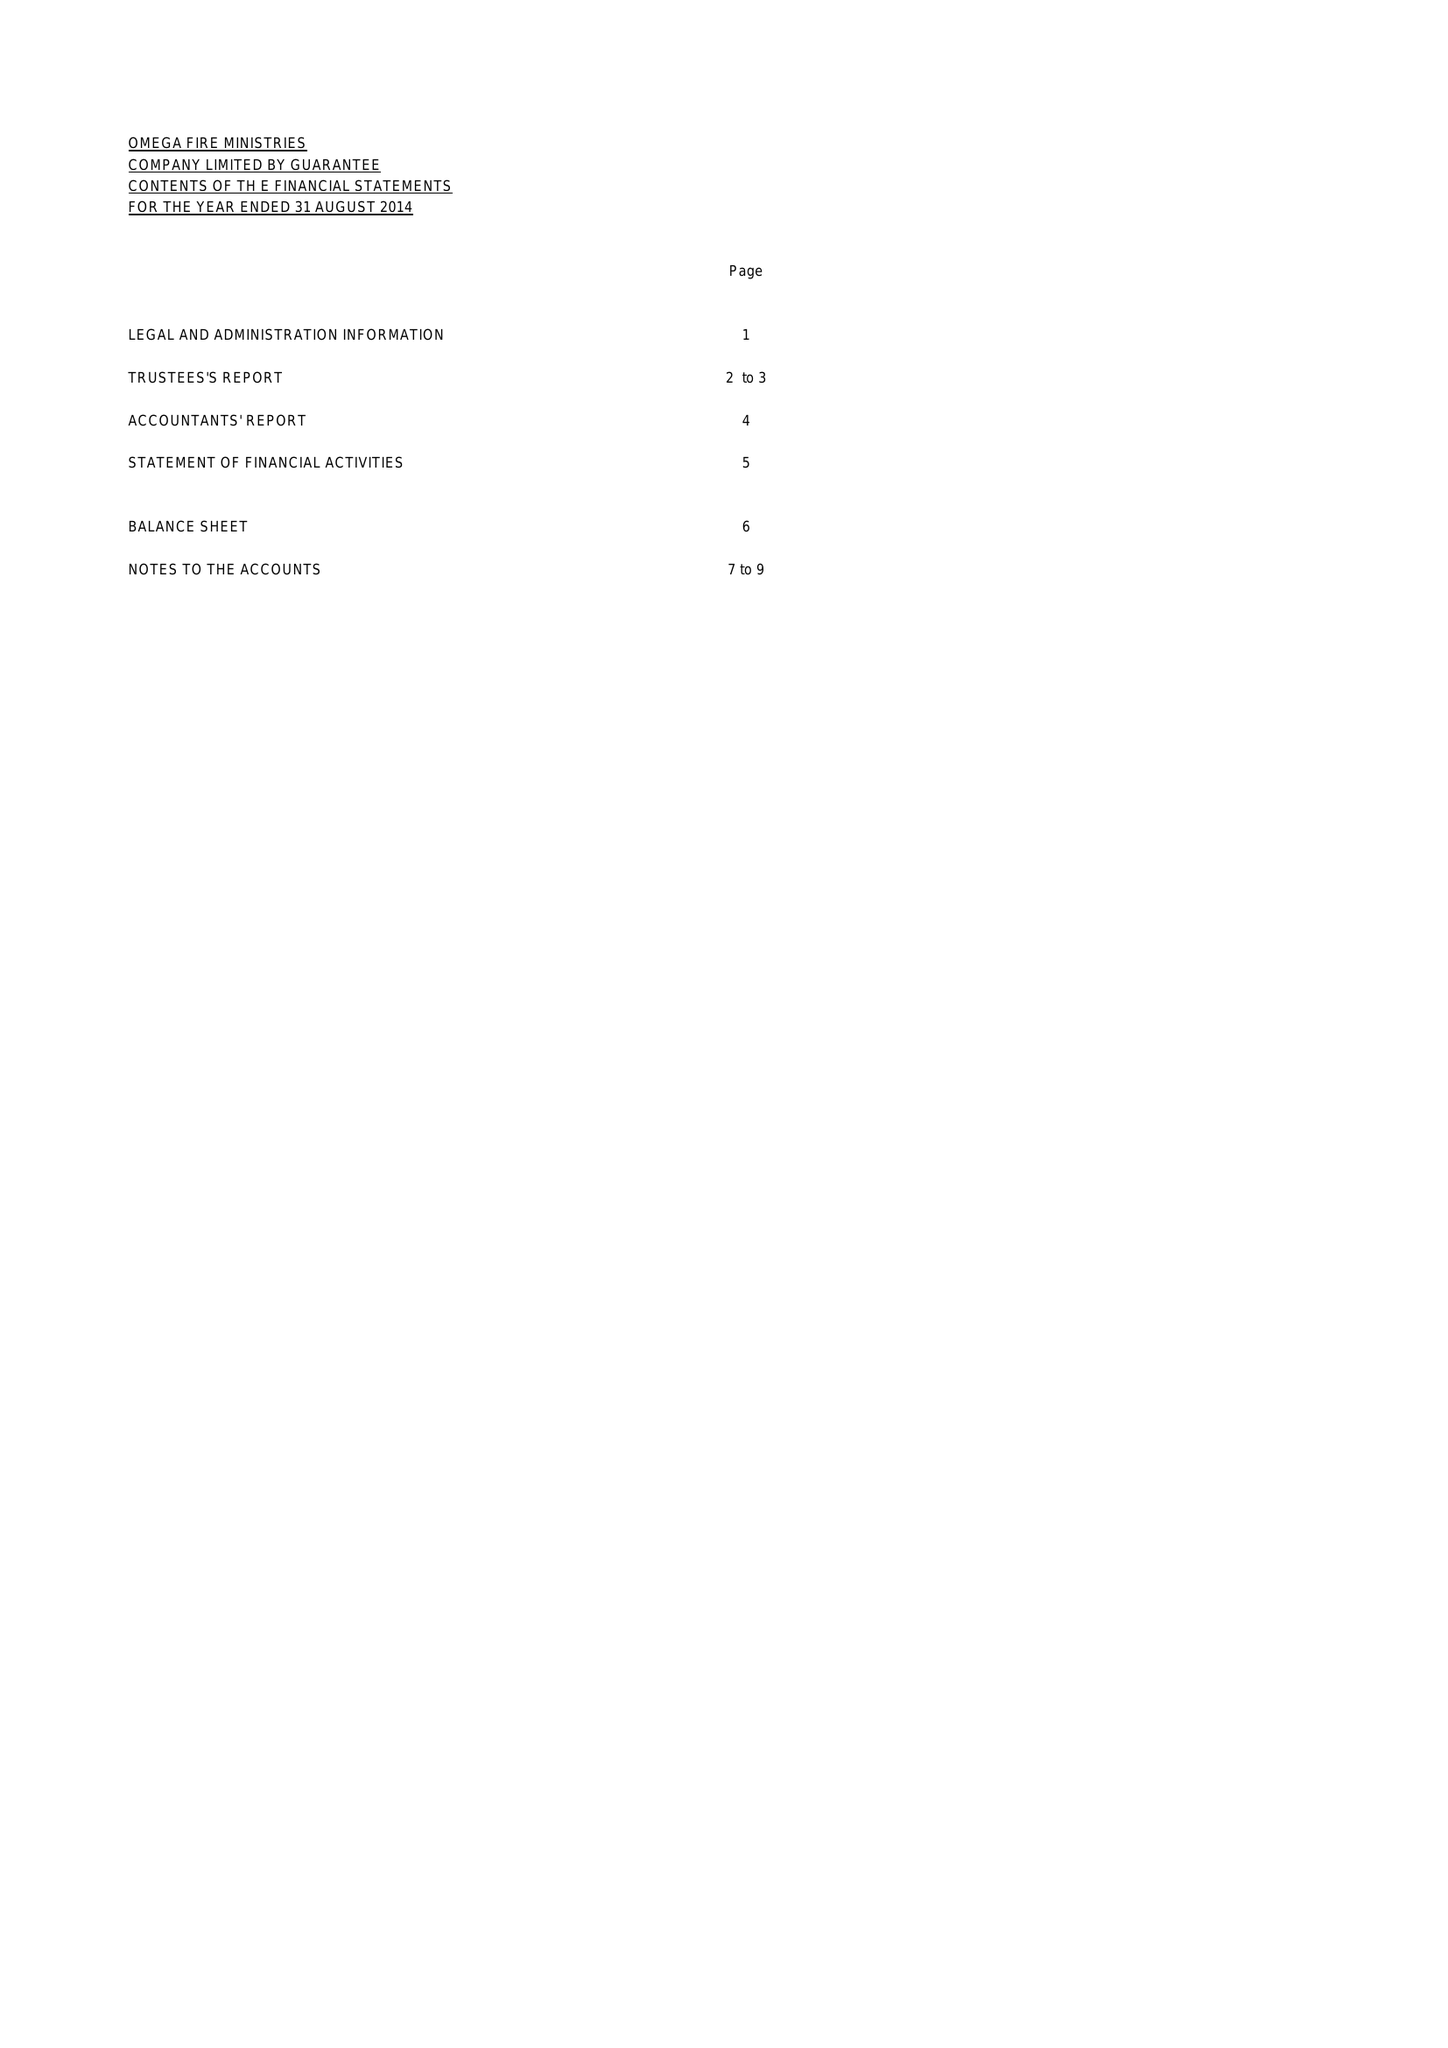What is the value for the report_date?
Answer the question using a single word or phrase. 2014-08-31 